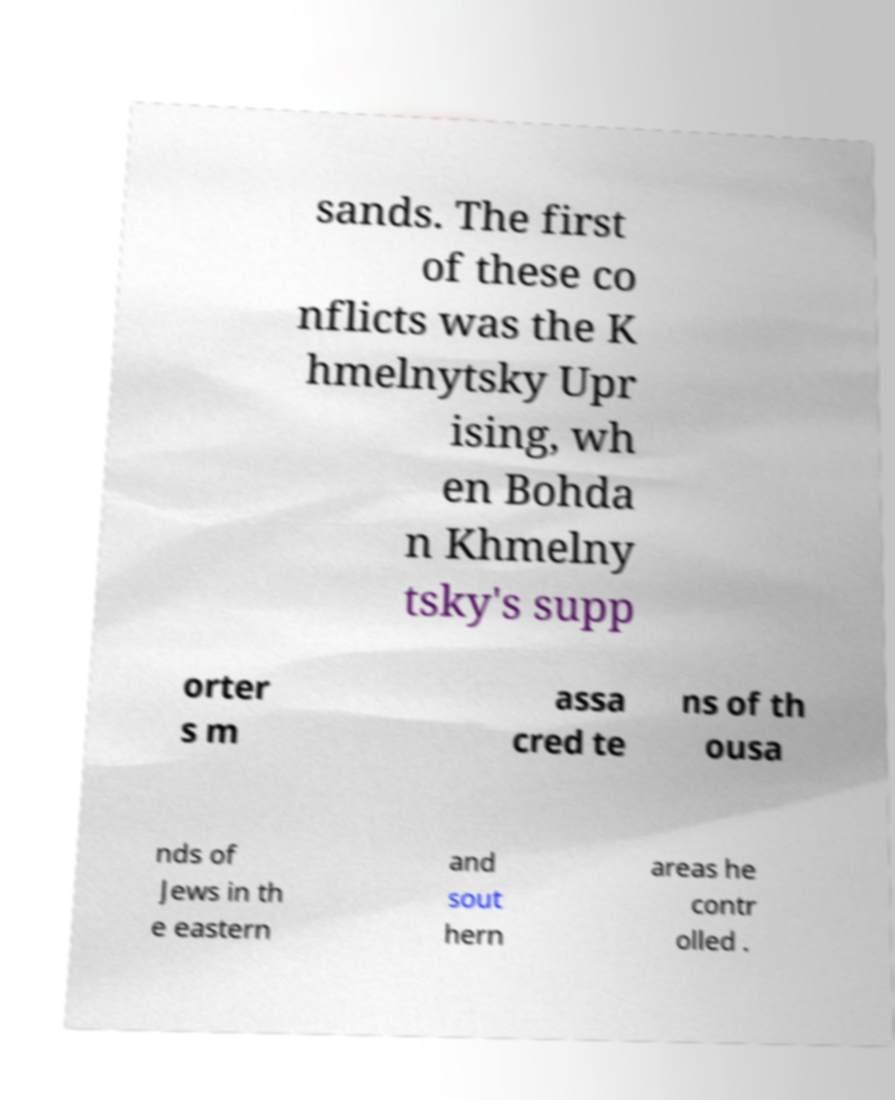For documentation purposes, I need the text within this image transcribed. Could you provide that? sands. The first of these co nflicts was the K hmelnytsky Upr ising, wh en Bohda n Khmelny tsky's supp orter s m assa cred te ns of th ousa nds of Jews in th e eastern and sout hern areas he contr olled . 